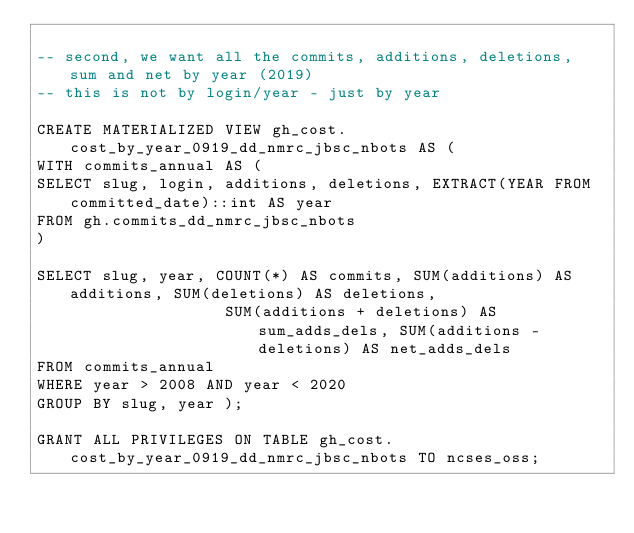<code> <loc_0><loc_0><loc_500><loc_500><_SQL_>
-- second, we want all the commits, additions, deletions, sum and net by year (2019)
-- this is not by login/year - just by year

CREATE MATERIALIZED VIEW gh_cost.cost_by_year_0919_dd_nmrc_jbsc_nbots AS (
WITH commits_annual AS (
SELECT slug, login, additions, deletions, EXTRACT(YEAR FROM committed_date)::int AS year
FROM gh.commits_dd_nmrc_jbsc_nbots
)

SELECT slug, year, COUNT(*) AS commits, SUM(additions) AS additions, SUM(deletions) AS deletions,
					SUM(additions + deletions) AS sum_adds_dels, SUM(additions - deletions) AS net_adds_dels
FROM commits_annual
WHERE year > 2008 AND year < 2020
GROUP BY slug, year );

GRANT ALL PRIVILEGES ON TABLE gh_cost.cost_by_year_0919_dd_nmrc_jbsc_nbots TO ncses_oss;
</code> 